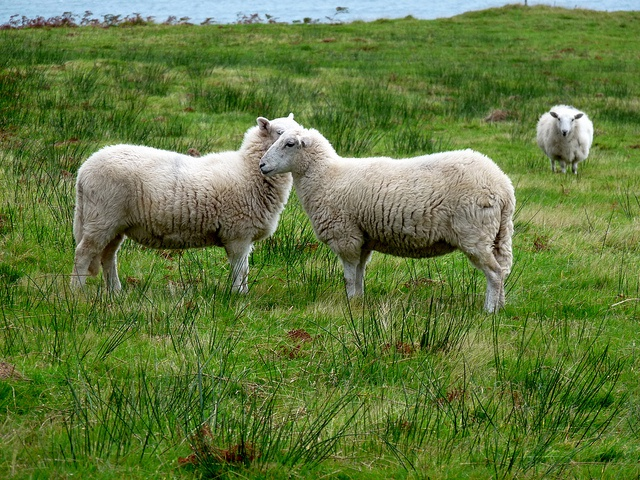Describe the objects in this image and their specific colors. I can see sheep in lightblue, darkgray, gray, lightgray, and black tones, sheep in lightblue, gray, lightgray, darkgray, and black tones, and sheep in lightblue, white, darkgray, gray, and darkgreen tones in this image. 